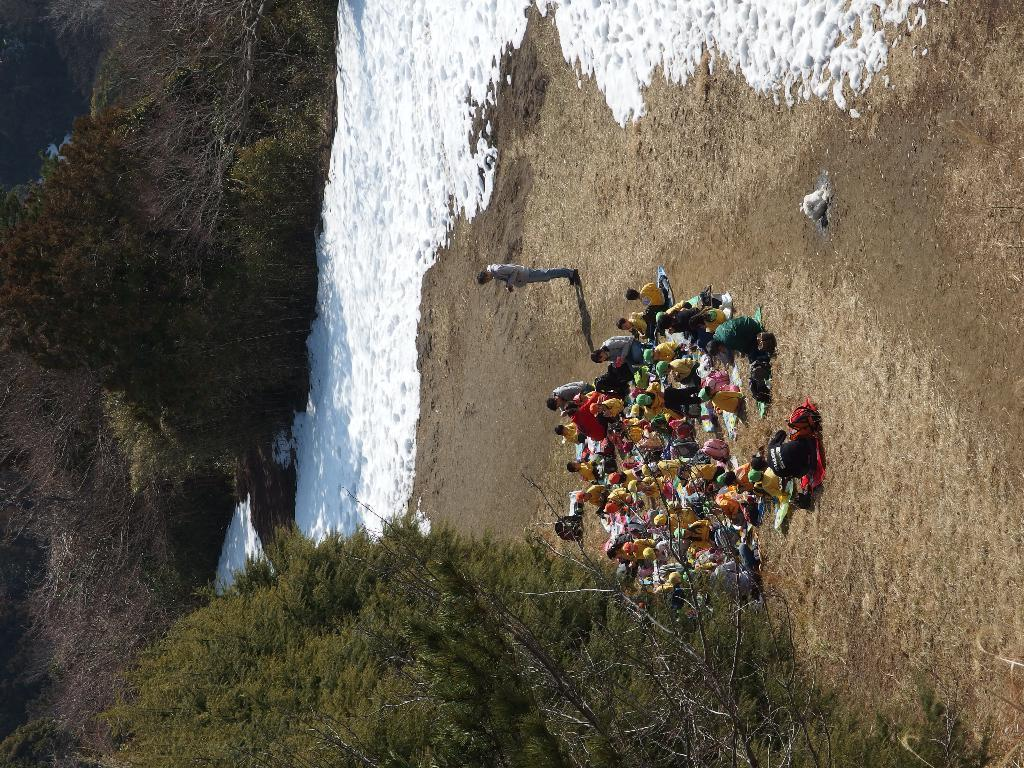What are the people in the image doing? The people in the image are sitting. What can be seen in the image besides the people? There are trees and a man standing in the image. What is visible in the background of the image? There is water visible in the background of the image. Reasoning: Let'g: Let's think step by step in order to produce the conversation. We start by identifying the main subjects in the image, which are the people. Then, we expand the conversation to include other objects and elements that are also visible, such as the trees, the man standing, and the water in the background. Each question is designed to elicit a specific detail about the image that is known from the provided facts. Absurd Question/Answer: What type of chalk is being used to draw on the trees in the image? There is no chalk or drawing on the trees in the image. How deep is the mine in the image? There is no mine present in the image. 